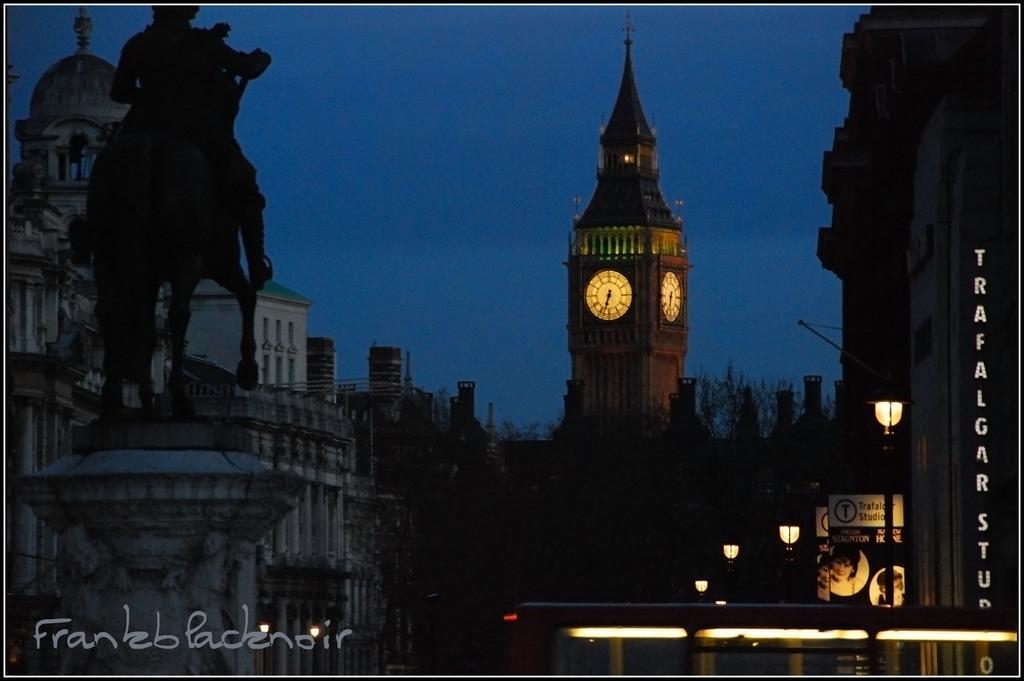Could you give a brief overview of what you see in this image? In this picture we can see buildings, poles, boards, and lights. There is a clock tower. In the background there is sky. 